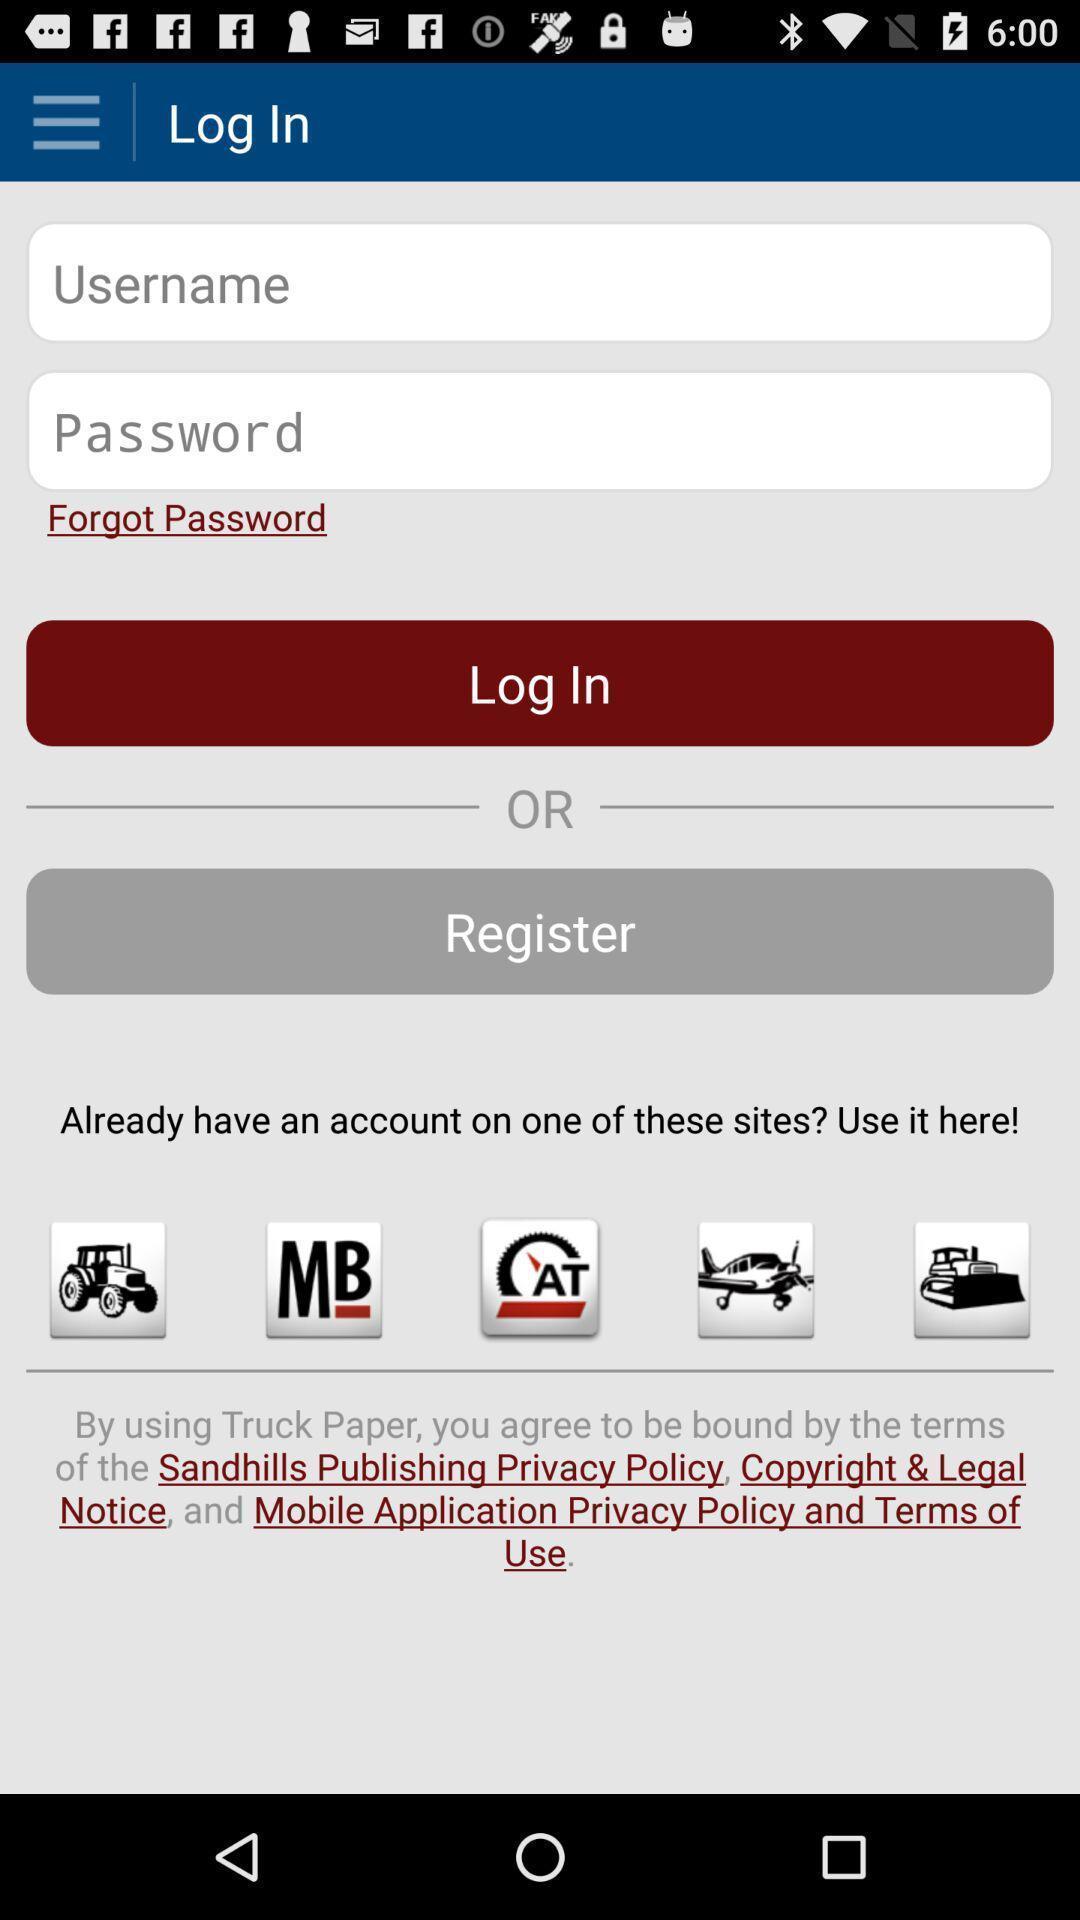Provide a detailed account of this screenshot. Screen displaying login page. 